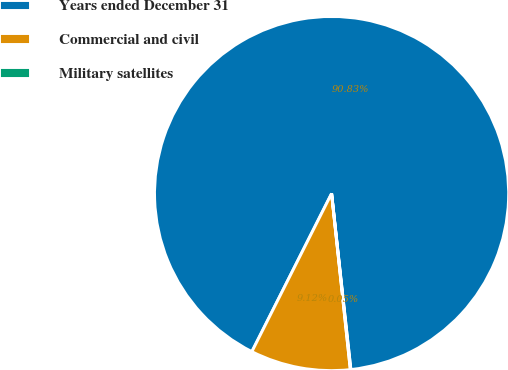<chart> <loc_0><loc_0><loc_500><loc_500><pie_chart><fcel>Years ended December 31<fcel>Commercial and civil<fcel>Military satellites<nl><fcel>90.83%<fcel>9.12%<fcel>0.05%<nl></chart> 